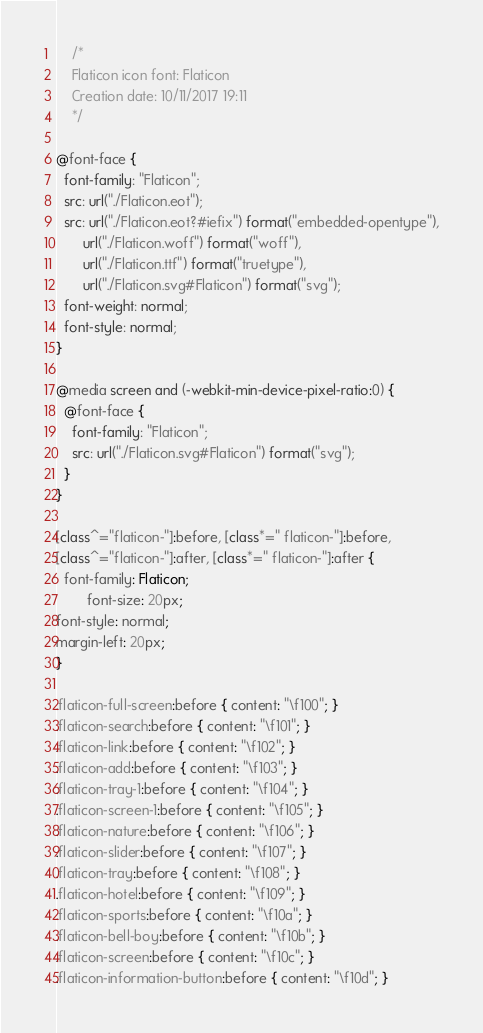<code> <loc_0><loc_0><loc_500><loc_500><_CSS_>	/*
  	Flaticon icon font: Flaticon
  	Creation date: 10/11/2017 19:11
  	*/

@font-face {
  font-family: "Flaticon";
  src: url("./Flaticon.eot");
  src: url("./Flaticon.eot?#iefix") format("embedded-opentype"),
       url("./Flaticon.woff") format("woff"),
       url("./Flaticon.ttf") format("truetype"),
       url("./Flaticon.svg#Flaticon") format("svg");
  font-weight: normal;
  font-style: normal;
}

@media screen and (-webkit-min-device-pixel-ratio:0) {
  @font-face {
    font-family: "Flaticon";
    src: url("./Flaticon.svg#Flaticon") format("svg");
  }
}

[class^="flaticon-"]:before, [class*=" flaticon-"]:before,
[class^="flaticon-"]:after, [class*=" flaticon-"]:after {   
  font-family: Flaticon;
        font-size: 20px;
font-style: normal;
margin-left: 20px;
}

.flaticon-full-screen:before { content: "\f100"; }
.flaticon-search:before { content: "\f101"; }
.flaticon-link:before { content: "\f102"; }
.flaticon-add:before { content: "\f103"; }
.flaticon-tray-1:before { content: "\f104"; }
.flaticon-screen-1:before { content: "\f105"; }
.flaticon-nature:before { content: "\f106"; }
.flaticon-slider:before { content: "\f107"; }
.flaticon-tray:before { content: "\f108"; }
.flaticon-hotel:before { content: "\f109"; }
.flaticon-sports:before { content: "\f10a"; }
.flaticon-bell-boy:before { content: "\f10b"; }
.flaticon-screen:before { content: "\f10c"; }
.flaticon-information-button:before { content: "\f10d"; }</code> 